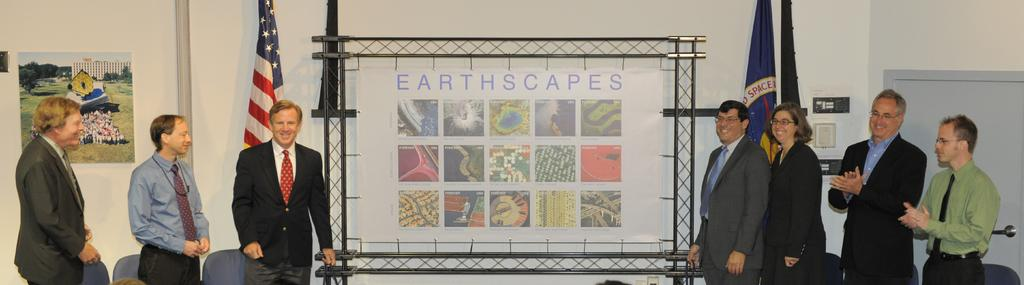What is the color of the banner in the image? The banner in the image is white. What type of images are on the banner? The banner has earthscapes and pictures on it. Are there any people near the banner? Yes, there are persons standing on either side of the banner. What type of plate is being used to hold the flame in the image? There is no plate or flame present in the image; it features a white banner with earthscapes and pictures, along with persons standing on either side of it. 